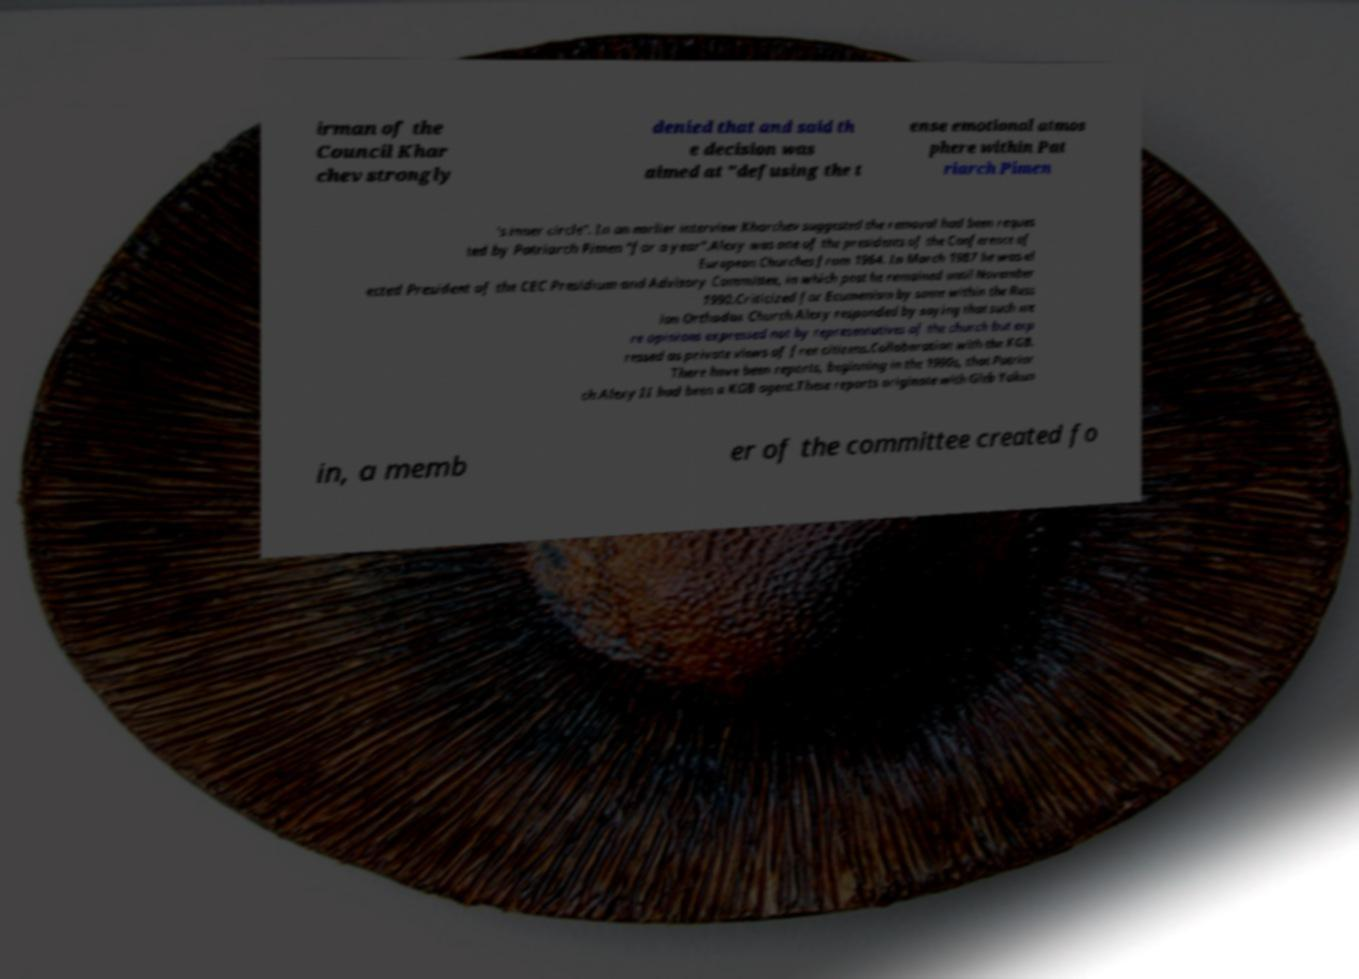Could you extract and type out the text from this image? irman of the Council Khar chev strongly denied that and said th e decision was aimed at "defusing the t ense emotional atmos phere within Pat riarch Pimen 's inner circle". In an earlier interview Kharchev suggested the removal had been reques ted by Patriarch Pimen "for a year".Alexy was one of the presidents of the Conference of European Churches from 1964. In March 1987 he was el ected President of the CEC Presidium and Advisory Committee, in which post he remained until November 1990.Criticized for Ecumenism by some within the Russ ian Orthodox Church Alexy responded by saying that such we re opinions expressed not by representatives of the church but exp ressed as private views of free citizens.Collaboration with the KGB. There have been reports, beginning in the 1990s, that Patriar ch Alexy II had been a KGB agent.These reports originate with Gleb Yakun in, a memb er of the committee created fo 